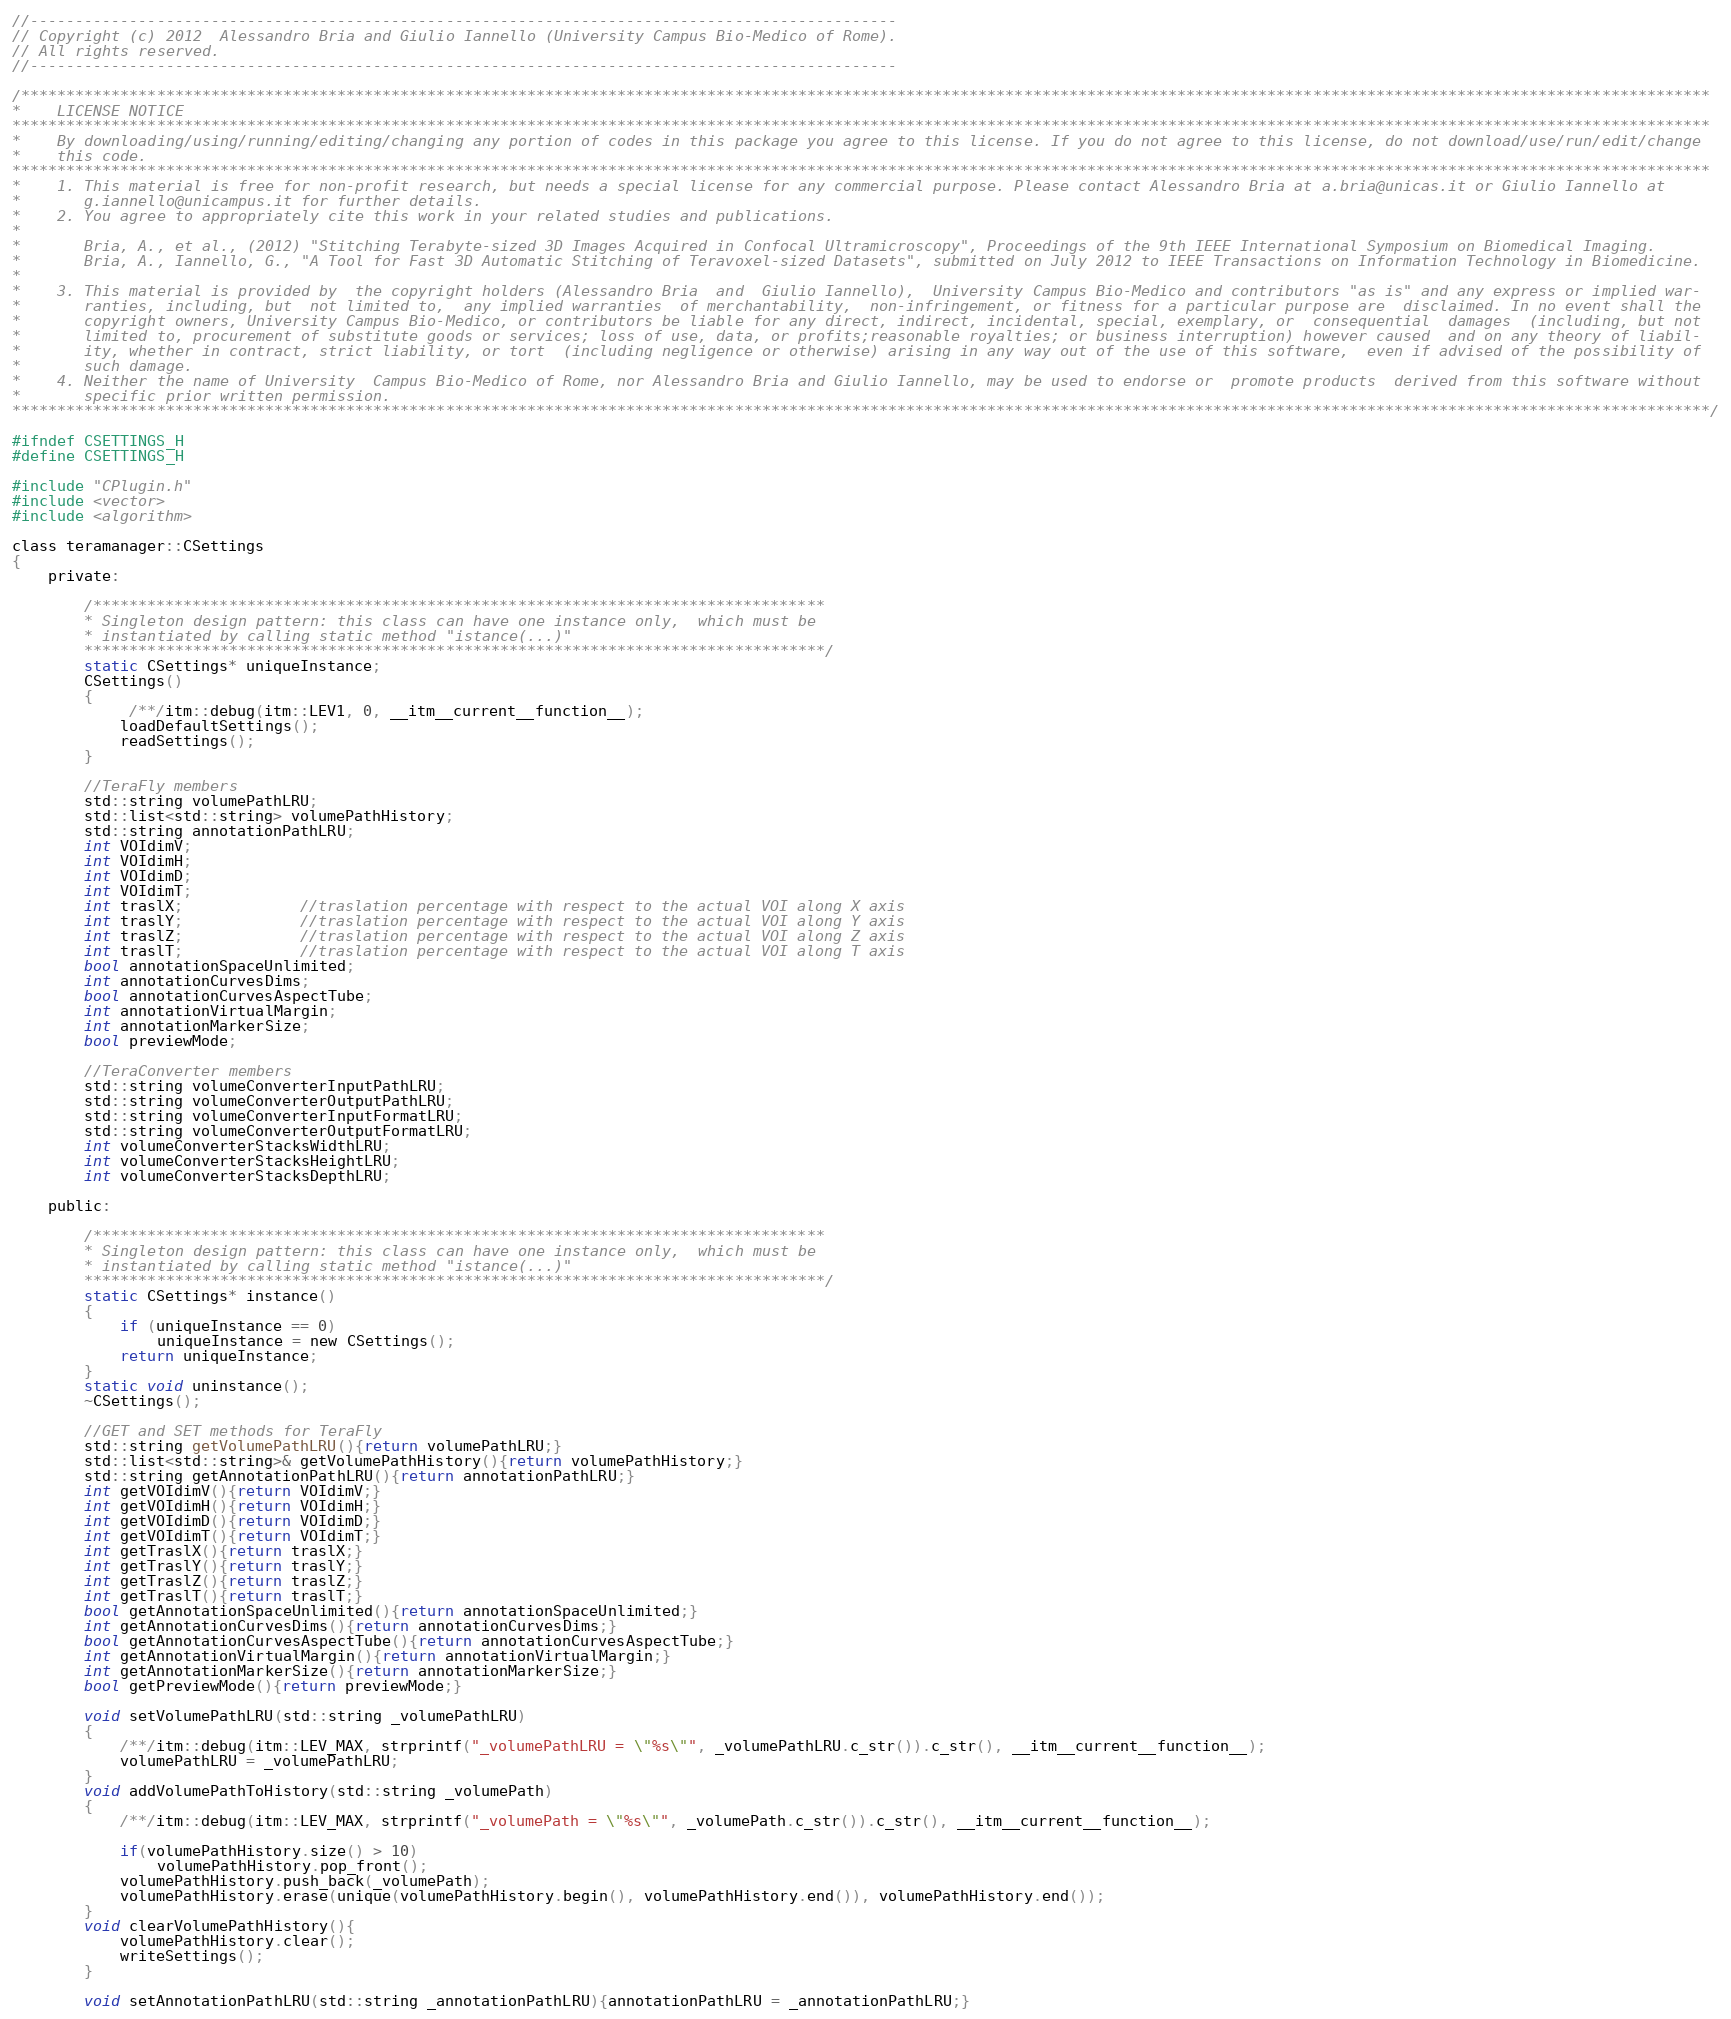<code> <loc_0><loc_0><loc_500><loc_500><_C_>//------------------------------------------------------------------------------------------------
// Copyright (c) 2012  Alessandro Bria and Giulio Iannello (University Campus Bio-Medico of Rome).
// All rights reserved.
//------------------------------------------------------------------------------------------------

/*******************************************************************************************************************************************************************************************
*    LICENSE NOTICE
********************************************************************************************************************************************************************************************
*    By downloading/using/running/editing/changing any portion of codes in this package you agree to this license. If you do not agree to this license, do not download/use/run/edit/change
*    this code.
********************************************************************************************************************************************************************************************
*    1. This material is free for non-profit research, but needs a special license for any commercial purpose. Please contact Alessandro Bria at a.bria@unicas.it or Giulio Iannello at
*       g.iannello@unicampus.it for further details.
*    2. You agree to appropriately cite this work in your related studies and publications.
*
*       Bria, A., et al., (2012) "Stitching Terabyte-sized 3D Images Acquired in Confocal Ultramicroscopy", Proceedings of the 9th IEEE International Symposium on Biomedical Imaging.
*       Bria, A., Iannello, G., "A Tool for Fast 3D Automatic Stitching of Teravoxel-sized Datasets", submitted on July 2012 to IEEE Transactions on Information Technology in Biomedicine.
*
*    3. This material is provided by  the copyright holders (Alessandro Bria  and  Giulio Iannello),  University Campus Bio-Medico and contributors "as is" and any express or implied war-
*       ranties, including, but  not limited to,  any implied warranties  of merchantability,  non-infringement, or fitness for a particular purpose are  disclaimed. In no event shall the
*       copyright owners, University Campus Bio-Medico, or contributors be liable for any direct, indirect, incidental, special, exemplary, or  consequential  damages  (including, but not
*       limited to, procurement of substitute goods or services; loss of use, data, or profits;reasonable royalties; or business interruption) however caused  and on any theory of liabil-
*       ity, whether in contract, strict liability, or tort  (including negligence or otherwise) arising in any way out of the use of this software,  even if advised of the possibility of
*       such damage.
*    4. Neither the name of University  Campus Bio-Medico of Rome, nor Alessandro Bria and Giulio Iannello, may be used to endorse or  promote products  derived from this software without
*       specific prior written permission.
********************************************************************************************************************************************************************************************/

#ifndef CSETTINGS_H
#define CSETTINGS_H

#include "CPlugin.h"
#include <vector>
#include <algorithm>

class teramanager::CSettings
{
    private:

        /*********************************************************************************
        * Singleton design pattern: this class can have one instance only,  which must be
        * instantiated by calling static method "istance(...)"
        **********************************************************************************/
        static CSettings* uniqueInstance;
        CSettings()
        {
             /**/itm::debug(itm::LEV1, 0, __itm__current__function__);
            loadDefaultSettings();
            readSettings();
        }

        //TeraFly members
		std::string volumePathLRU;
        std::list<std::string> volumePathHistory;
		std::string annotationPathLRU;
        int VOIdimV;
        int VOIdimH;
        int VOIdimD;
        int VOIdimT;
        int traslX;             //traslation percentage with respect to the actual VOI along X axis
        int traslY;             //traslation percentage with respect to the actual VOI along Y axis
        int traslZ;             //traslation percentage with respect to the actual VOI along Z axis
        int traslT;             //traslation percentage with respect to the actual VOI along T axis
        bool annotationSpaceUnlimited;
        int annotationCurvesDims;
        bool annotationCurvesAspectTube;
        int annotationVirtualMargin;
        int annotationMarkerSize;
        bool previewMode;

        //TeraConverter members
        std::string volumeConverterInputPathLRU;
        std::string volumeConverterOutputPathLRU;
        std::string volumeConverterInputFormatLRU;
        std::string volumeConverterOutputFormatLRU;
        int volumeConverterStacksWidthLRU;
        int volumeConverterStacksHeightLRU;
        int volumeConverterStacksDepthLRU;

    public:

        /*********************************************************************************
        * Singleton design pattern: this class can have one instance only,  which must be
        * instantiated by calling static method "istance(...)"
        **********************************************************************************/
        static CSettings* instance()
        {
            if (uniqueInstance == 0)
                uniqueInstance = new CSettings();
            return uniqueInstance;
        }
        static void uninstance();
        ~CSettings();

        //GET and SET methods for TeraFly
        std::string getVolumePathLRU(){return volumePathLRU;}
        std::list<std::string>& getVolumePathHistory(){return volumePathHistory;}
        std::string getAnnotationPathLRU(){return annotationPathLRU;}
        int getVOIdimV(){return VOIdimV;}
        int getVOIdimH(){return VOIdimH;}
        int getVOIdimD(){return VOIdimD;}
        int getVOIdimT(){return VOIdimT;}
        int getTraslX(){return traslX;}
        int getTraslY(){return traslY;}
        int getTraslZ(){return traslZ;}
        int getTraslT(){return traslT;}
        bool getAnnotationSpaceUnlimited(){return annotationSpaceUnlimited;}
        int getAnnotationCurvesDims(){return annotationCurvesDims;}
        bool getAnnotationCurvesAspectTube(){return annotationCurvesAspectTube;}
        int getAnnotationVirtualMargin(){return annotationVirtualMargin;}
        int getAnnotationMarkerSize(){return annotationMarkerSize;}
        bool getPreviewMode(){return previewMode;}

        void setVolumePathLRU(std::string _volumePathLRU)
        {
            /**/itm::debug(itm::LEV_MAX, strprintf("_volumePathLRU = \"%s\"", _volumePathLRU.c_str()).c_str(), __itm__current__function__);
            volumePathLRU = _volumePathLRU;
        }
        void addVolumePathToHistory(std::string _volumePath)
        {
            /**/itm::debug(itm::LEV_MAX, strprintf("_volumePath = \"%s\"", _volumePath.c_str()).c_str(), __itm__current__function__);

            if(volumePathHistory.size() > 10)
                volumePathHistory.pop_front();
            volumePathHistory.push_back(_volumePath);
            volumePathHistory.erase(unique(volumePathHistory.begin(), volumePathHistory.end()), volumePathHistory.end());
        }
        void clearVolumePathHistory(){
            volumePathHistory.clear();
            writeSettings();
        }

        void setAnnotationPathLRU(std::string _annotationPathLRU){annotationPathLRU = _annotationPathLRU;}</code> 